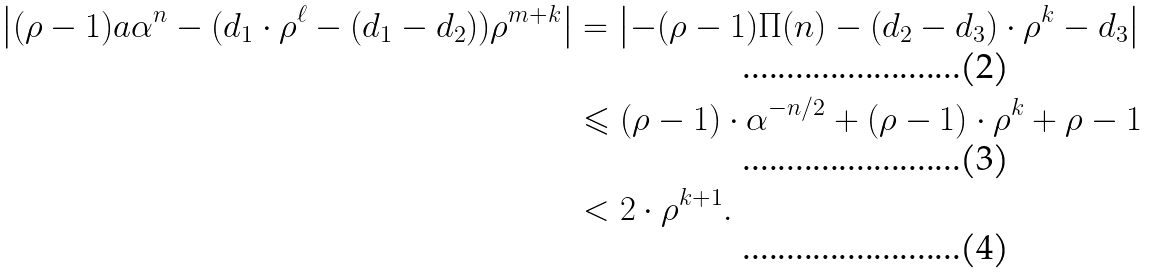Convert formula to latex. <formula><loc_0><loc_0><loc_500><loc_500>\left | ( \rho - 1 ) a \alpha ^ { n } - ( d _ { 1 } \cdot \rho ^ { \ell } - ( d _ { 1 } - d _ { 2 } ) ) \rho ^ { m + k } \right | & = \left | - ( \rho - 1 ) \Pi ( n ) - ( d _ { 2 } - d _ { 3 } ) \cdot \rho ^ { k } - d _ { 3 } \right | \\ & \leqslant ( \rho - 1 ) \cdot \alpha ^ { - n / 2 } + ( \rho - 1 ) \cdot \rho ^ { k } + \rho - 1 \\ & < 2 \cdot \rho ^ { k + 1 } .</formula> 